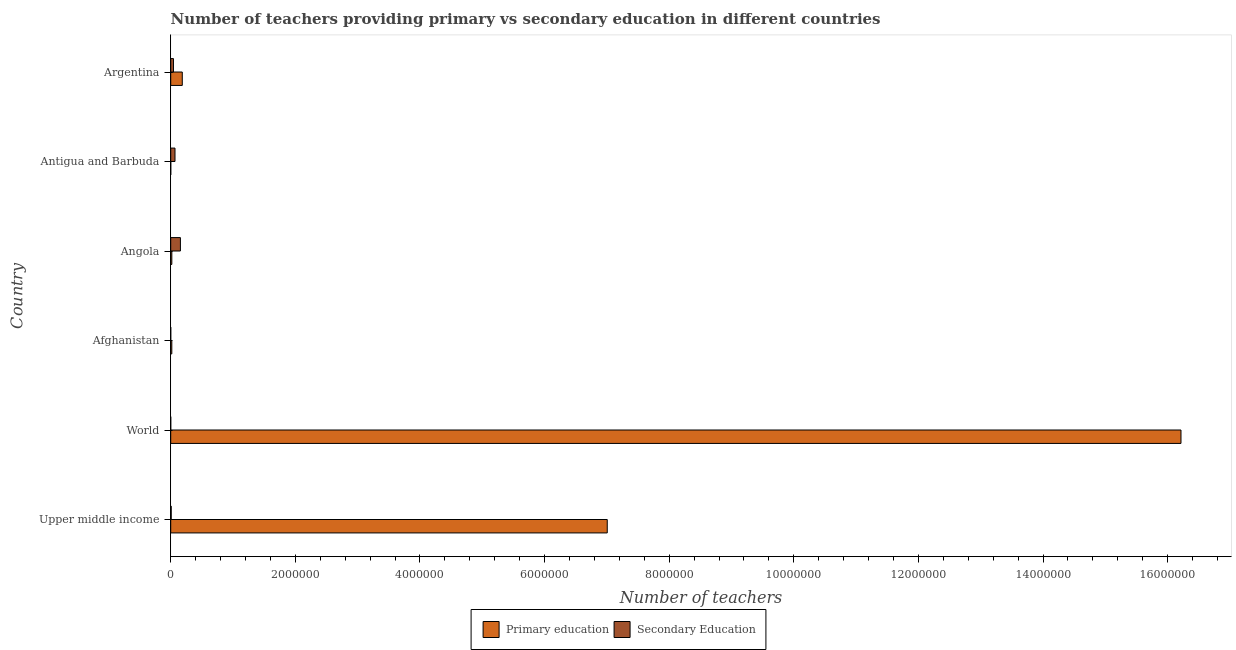How many different coloured bars are there?
Ensure brevity in your answer.  2. What is the label of the 6th group of bars from the top?
Provide a short and direct response. Upper middle income. What is the number of secondary teachers in Argentina?
Provide a short and direct response. 4.41e+04. Across all countries, what is the maximum number of primary teachers?
Offer a very short reply. 1.62e+07. Across all countries, what is the minimum number of secondary teachers?
Ensure brevity in your answer.  125. In which country was the number of primary teachers maximum?
Offer a very short reply. World. In which country was the number of primary teachers minimum?
Your answer should be compact. Antigua and Barbuda. What is the total number of primary teachers in the graph?
Provide a short and direct response. 2.34e+07. What is the difference between the number of secondary teachers in Antigua and Barbuda and that in Argentina?
Make the answer very short. 2.46e+04. What is the difference between the number of secondary teachers in Argentina and the number of primary teachers in Antigua and Barbuda?
Your answer should be compact. 4.36e+04. What is the average number of primary teachers per country?
Your response must be concise. 3.91e+06. What is the difference between the number of primary teachers and number of secondary teachers in Afghanistan?
Make the answer very short. 1.73e+04. In how many countries, is the number of primary teachers greater than 6000000 ?
Your answer should be compact. 2. What is the ratio of the number of primary teachers in Afghanistan to that in Angola?
Your answer should be very brief. 0.99. Is the difference between the number of secondary teachers in Angola and World greater than the difference between the number of primary teachers in Angola and World?
Offer a terse response. Yes. What is the difference between the highest and the second highest number of primary teachers?
Your answer should be very brief. 9.21e+06. What is the difference between the highest and the lowest number of secondary teachers?
Your response must be concise. 1.55e+05. In how many countries, is the number of primary teachers greater than the average number of primary teachers taken over all countries?
Give a very brief answer. 2. What does the 2nd bar from the top in Afghanistan represents?
Keep it short and to the point. Primary education. What does the 1st bar from the bottom in Afghanistan represents?
Give a very brief answer. Primary education. How many countries are there in the graph?
Offer a terse response. 6. Are the values on the major ticks of X-axis written in scientific E-notation?
Make the answer very short. No. Does the graph contain any zero values?
Ensure brevity in your answer.  No. How are the legend labels stacked?
Give a very brief answer. Horizontal. What is the title of the graph?
Ensure brevity in your answer.  Number of teachers providing primary vs secondary education in different countries. What is the label or title of the X-axis?
Your answer should be very brief. Number of teachers. What is the label or title of the Y-axis?
Keep it short and to the point. Country. What is the Number of teachers in Primary education in Upper middle income?
Your answer should be very brief. 7.01e+06. What is the Number of teachers in Secondary Education in Upper middle income?
Give a very brief answer. 7866. What is the Number of teachers in Primary education in World?
Keep it short and to the point. 1.62e+07. What is the Number of teachers in Secondary Education in World?
Your answer should be compact. 125. What is the Number of teachers in Primary education in Afghanistan?
Offer a terse response. 1.76e+04. What is the Number of teachers of Secondary Education in Afghanistan?
Ensure brevity in your answer.  326. What is the Number of teachers in Primary education in Angola?
Your answer should be very brief. 1.78e+04. What is the Number of teachers of Secondary Education in Angola?
Keep it short and to the point. 1.55e+05. What is the Number of teachers in Primary education in Antigua and Barbuda?
Your answer should be compact. 440. What is the Number of teachers of Secondary Education in Antigua and Barbuda?
Ensure brevity in your answer.  6.86e+04. What is the Number of teachers of Primary education in Argentina?
Offer a terse response. 1.86e+05. What is the Number of teachers of Secondary Education in Argentina?
Offer a terse response. 4.41e+04. Across all countries, what is the maximum Number of teachers in Primary education?
Give a very brief answer. 1.62e+07. Across all countries, what is the maximum Number of teachers of Secondary Education?
Your answer should be compact. 1.55e+05. Across all countries, what is the minimum Number of teachers in Primary education?
Provide a short and direct response. 440. Across all countries, what is the minimum Number of teachers of Secondary Education?
Give a very brief answer. 125. What is the total Number of teachers of Primary education in the graph?
Provide a short and direct response. 2.34e+07. What is the total Number of teachers in Secondary Education in the graph?
Keep it short and to the point. 2.76e+05. What is the difference between the Number of teachers of Primary education in Upper middle income and that in World?
Keep it short and to the point. -9.21e+06. What is the difference between the Number of teachers in Secondary Education in Upper middle income and that in World?
Give a very brief answer. 7741. What is the difference between the Number of teachers in Primary education in Upper middle income and that in Afghanistan?
Keep it short and to the point. 6.99e+06. What is the difference between the Number of teachers of Secondary Education in Upper middle income and that in Afghanistan?
Offer a terse response. 7540. What is the difference between the Number of teachers of Primary education in Upper middle income and that in Angola?
Offer a very short reply. 6.99e+06. What is the difference between the Number of teachers of Secondary Education in Upper middle income and that in Angola?
Provide a succinct answer. -1.48e+05. What is the difference between the Number of teachers in Primary education in Upper middle income and that in Antigua and Barbuda?
Offer a very short reply. 7.01e+06. What is the difference between the Number of teachers of Secondary Education in Upper middle income and that in Antigua and Barbuda?
Provide a succinct answer. -6.08e+04. What is the difference between the Number of teachers of Primary education in Upper middle income and that in Argentina?
Your answer should be very brief. 6.82e+06. What is the difference between the Number of teachers in Secondary Education in Upper middle income and that in Argentina?
Provide a succinct answer. -3.62e+04. What is the difference between the Number of teachers in Primary education in World and that in Afghanistan?
Offer a terse response. 1.62e+07. What is the difference between the Number of teachers of Secondary Education in World and that in Afghanistan?
Offer a terse response. -201. What is the difference between the Number of teachers of Primary education in World and that in Angola?
Your answer should be compact. 1.62e+07. What is the difference between the Number of teachers in Secondary Education in World and that in Angola?
Keep it short and to the point. -1.55e+05. What is the difference between the Number of teachers in Primary education in World and that in Antigua and Barbuda?
Keep it short and to the point. 1.62e+07. What is the difference between the Number of teachers of Secondary Education in World and that in Antigua and Barbuda?
Make the answer very short. -6.85e+04. What is the difference between the Number of teachers of Primary education in World and that in Argentina?
Your answer should be compact. 1.60e+07. What is the difference between the Number of teachers in Secondary Education in World and that in Argentina?
Make the answer very short. -4.39e+04. What is the difference between the Number of teachers in Primary education in Afghanistan and that in Angola?
Give a very brief answer. -252. What is the difference between the Number of teachers of Secondary Education in Afghanistan and that in Angola?
Keep it short and to the point. -1.55e+05. What is the difference between the Number of teachers in Primary education in Afghanistan and that in Antigua and Barbuda?
Make the answer very short. 1.71e+04. What is the difference between the Number of teachers of Secondary Education in Afghanistan and that in Antigua and Barbuda?
Give a very brief answer. -6.83e+04. What is the difference between the Number of teachers in Primary education in Afghanistan and that in Argentina?
Give a very brief answer. -1.68e+05. What is the difference between the Number of teachers in Secondary Education in Afghanistan and that in Argentina?
Offer a terse response. -4.37e+04. What is the difference between the Number of teachers in Primary education in Angola and that in Antigua and Barbuda?
Your answer should be very brief. 1.74e+04. What is the difference between the Number of teachers in Secondary Education in Angola and that in Antigua and Barbuda?
Your response must be concise. 8.69e+04. What is the difference between the Number of teachers of Primary education in Angola and that in Argentina?
Your response must be concise. -1.68e+05. What is the difference between the Number of teachers of Secondary Education in Angola and that in Argentina?
Offer a very short reply. 1.11e+05. What is the difference between the Number of teachers in Primary education in Antigua and Barbuda and that in Argentina?
Provide a short and direct response. -1.85e+05. What is the difference between the Number of teachers in Secondary Education in Antigua and Barbuda and that in Argentina?
Your answer should be compact. 2.46e+04. What is the difference between the Number of teachers in Primary education in Upper middle income and the Number of teachers in Secondary Education in World?
Offer a terse response. 7.01e+06. What is the difference between the Number of teachers in Primary education in Upper middle income and the Number of teachers in Secondary Education in Afghanistan?
Give a very brief answer. 7.01e+06. What is the difference between the Number of teachers in Primary education in Upper middle income and the Number of teachers in Secondary Education in Angola?
Your answer should be very brief. 6.85e+06. What is the difference between the Number of teachers in Primary education in Upper middle income and the Number of teachers in Secondary Education in Antigua and Barbuda?
Provide a succinct answer. 6.94e+06. What is the difference between the Number of teachers in Primary education in Upper middle income and the Number of teachers in Secondary Education in Argentina?
Provide a succinct answer. 6.96e+06. What is the difference between the Number of teachers of Primary education in World and the Number of teachers of Secondary Education in Afghanistan?
Your answer should be very brief. 1.62e+07. What is the difference between the Number of teachers in Primary education in World and the Number of teachers in Secondary Education in Angola?
Offer a very short reply. 1.61e+07. What is the difference between the Number of teachers in Primary education in World and the Number of teachers in Secondary Education in Antigua and Barbuda?
Offer a very short reply. 1.61e+07. What is the difference between the Number of teachers in Primary education in World and the Number of teachers in Secondary Education in Argentina?
Provide a short and direct response. 1.62e+07. What is the difference between the Number of teachers of Primary education in Afghanistan and the Number of teachers of Secondary Education in Angola?
Make the answer very short. -1.38e+05. What is the difference between the Number of teachers of Primary education in Afghanistan and the Number of teachers of Secondary Education in Antigua and Barbuda?
Give a very brief answer. -5.10e+04. What is the difference between the Number of teachers of Primary education in Afghanistan and the Number of teachers of Secondary Education in Argentina?
Your response must be concise. -2.65e+04. What is the difference between the Number of teachers of Primary education in Angola and the Number of teachers of Secondary Education in Antigua and Barbuda?
Your response must be concise. -5.08e+04. What is the difference between the Number of teachers in Primary education in Angola and the Number of teachers in Secondary Education in Argentina?
Provide a short and direct response. -2.62e+04. What is the difference between the Number of teachers in Primary education in Antigua and Barbuda and the Number of teachers in Secondary Education in Argentina?
Keep it short and to the point. -4.36e+04. What is the average Number of teachers of Primary education per country?
Your answer should be very brief. 3.91e+06. What is the average Number of teachers in Secondary Education per country?
Offer a terse response. 4.61e+04. What is the difference between the Number of teachers in Primary education and Number of teachers in Secondary Education in Upper middle income?
Make the answer very short. 7.00e+06. What is the difference between the Number of teachers of Primary education and Number of teachers of Secondary Education in World?
Your answer should be compact. 1.62e+07. What is the difference between the Number of teachers in Primary education and Number of teachers in Secondary Education in Afghanistan?
Your response must be concise. 1.73e+04. What is the difference between the Number of teachers of Primary education and Number of teachers of Secondary Education in Angola?
Ensure brevity in your answer.  -1.38e+05. What is the difference between the Number of teachers in Primary education and Number of teachers in Secondary Education in Antigua and Barbuda?
Offer a terse response. -6.82e+04. What is the difference between the Number of teachers in Primary education and Number of teachers in Secondary Education in Argentina?
Your answer should be very brief. 1.42e+05. What is the ratio of the Number of teachers in Primary education in Upper middle income to that in World?
Your response must be concise. 0.43. What is the ratio of the Number of teachers in Secondary Education in Upper middle income to that in World?
Provide a short and direct response. 62.93. What is the ratio of the Number of teachers in Primary education in Upper middle income to that in Afghanistan?
Ensure brevity in your answer.  398.56. What is the ratio of the Number of teachers of Secondary Education in Upper middle income to that in Afghanistan?
Make the answer very short. 24.13. What is the ratio of the Number of teachers in Primary education in Upper middle income to that in Angola?
Offer a very short reply. 392.93. What is the ratio of the Number of teachers in Secondary Education in Upper middle income to that in Angola?
Provide a succinct answer. 0.05. What is the ratio of the Number of teachers in Primary education in Upper middle income to that in Antigua and Barbuda?
Make the answer very short. 1.59e+04. What is the ratio of the Number of teachers of Secondary Education in Upper middle income to that in Antigua and Barbuda?
Your answer should be compact. 0.11. What is the ratio of the Number of teachers in Primary education in Upper middle income to that in Argentina?
Offer a very short reply. 37.76. What is the ratio of the Number of teachers in Secondary Education in Upper middle income to that in Argentina?
Offer a terse response. 0.18. What is the ratio of the Number of teachers of Primary education in World to that in Afghanistan?
Provide a short and direct response. 922.39. What is the ratio of the Number of teachers of Secondary Education in World to that in Afghanistan?
Your answer should be compact. 0.38. What is the ratio of the Number of teachers of Primary education in World to that in Angola?
Your answer should be very brief. 909.35. What is the ratio of the Number of teachers in Secondary Education in World to that in Angola?
Make the answer very short. 0. What is the ratio of the Number of teachers in Primary education in World to that in Antigua and Barbuda?
Give a very brief answer. 3.69e+04. What is the ratio of the Number of teachers in Secondary Education in World to that in Antigua and Barbuda?
Keep it short and to the point. 0. What is the ratio of the Number of teachers of Primary education in World to that in Argentina?
Give a very brief answer. 87.38. What is the ratio of the Number of teachers of Secondary Education in World to that in Argentina?
Provide a short and direct response. 0. What is the ratio of the Number of teachers of Primary education in Afghanistan to that in Angola?
Give a very brief answer. 0.99. What is the ratio of the Number of teachers of Secondary Education in Afghanistan to that in Angola?
Your answer should be compact. 0. What is the ratio of the Number of teachers of Primary education in Afghanistan to that in Antigua and Barbuda?
Provide a succinct answer. 39.95. What is the ratio of the Number of teachers of Secondary Education in Afghanistan to that in Antigua and Barbuda?
Your response must be concise. 0. What is the ratio of the Number of teachers in Primary education in Afghanistan to that in Argentina?
Make the answer very short. 0.09. What is the ratio of the Number of teachers of Secondary Education in Afghanistan to that in Argentina?
Your answer should be very brief. 0.01. What is the ratio of the Number of teachers in Primary education in Angola to that in Antigua and Barbuda?
Your response must be concise. 40.52. What is the ratio of the Number of teachers of Secondary Education in Angola to that in Antigua and Barbuda?
Give a very brief answer. 2.27. What is the ratio of the Number of teachers of Primary education in Angola to that in Argentina?
Keep it short and to the point. 0.1. What is the ratio of the Number of teachers in Secondary Education in Angola to that in Argentina?
Your answer should be very brief. 3.53. What is the ratio of the Number of teachers in Primary education in Antigua and Barbuda to that in Argentina?
Provide a short and direct response. 0. What is the ratio of the Number of teachers in Secondary Education in Antigua and Barbuda to that in Argentina?
Offer a very short reply. 1.56. What is the difference between the highest and the second highest Number of teachers of Primary education?
Offer a very short reply. 9.21e+06. What is the difference between the highest and the second highest Number of teachers of Secondary Education?
Make the answer very short. 8.69e+04. What is the difference between the highest and the lowest Number of teachers of Primary education?
Your response must be concise. 1.62e+07. What is the difference between the highest and the lowest Number of teachers in Secondary Education?
Your response must be concise. 1.55e+05. 